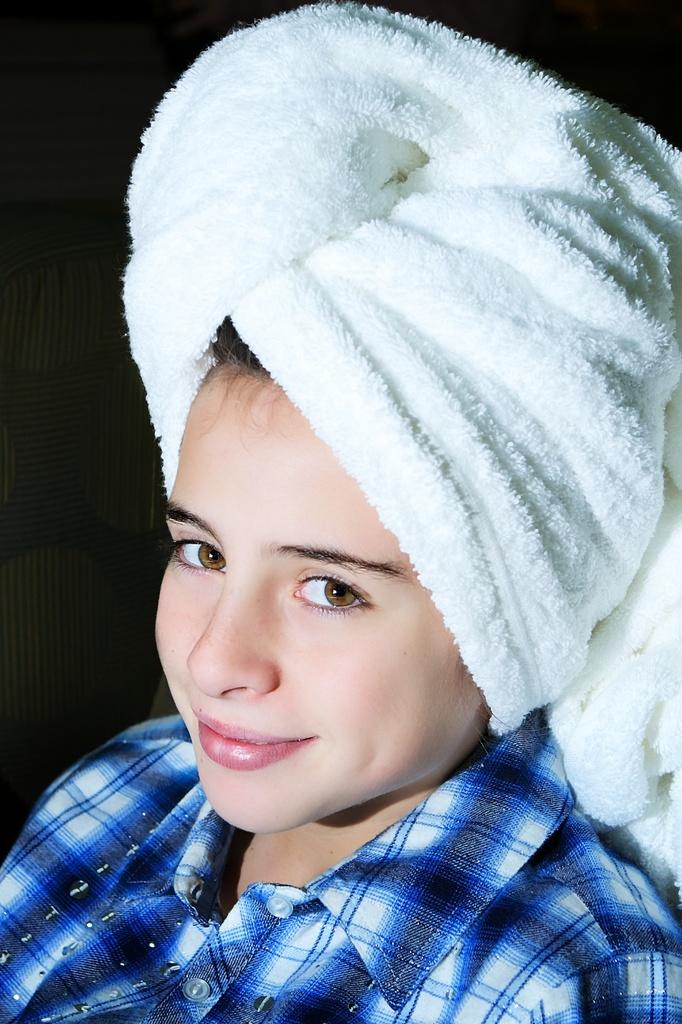Who is the main subject in the image? There is a lady in the center of the image. What is the lady wearing on her upper body? The lady is wearing a blue color shirt. What is the lady using to cover her head? The lady has a white color towel wrapped around her head. What type of skirt is the lady wearing in the image? The lady is not wearing a skirt in the image; she is wearing a blue color shirt and a white color towel wrapped around her head. What is the relation between the lady and the giants in the image? There are no giants present in the image, so there is no relation between the lady and any giants. 